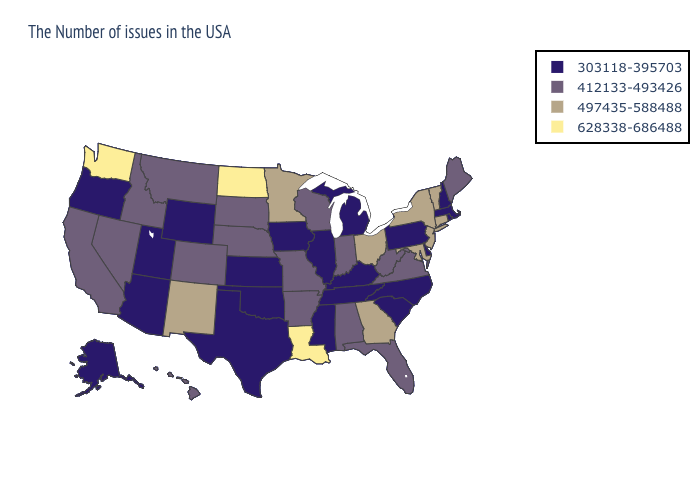Name the states that have a value in the range 497435-588488?
Give a very brief answer. Vermont, Connecticut, New York, New Jersey, Maryland, Ohio, Georgia, Minnesota, New Mexico. Which states have the highest value in the USA?
Quick response, please. Louisiana, North Dakota, Washington. Does South Carolina have the same value as Utah?
Give a very brief answer. Yes. Does Illinois have the lowest value in the USA?
Short answer required. Yes. Does Alabama have the lowest value in the South?
Write a very short answer. No. Which states have the lowest value in the Northeast?
Concise answer only. Massachusetts, Rhode Island, New Hampshire, Pennsylvania. Which states hav the highest value in the Northeast?
Quick response, please. Vermont, Connecticut, New York, New Jersey. Does West Virginia have the highest value in the South?
Concise answer only. No. What is the value of Arizona?
Quick response, please. 303118-395703. Does Alaska have a lower value than Maryland?
Quick response, please. Yes. Name the states that have a value in the range 497435-588488?
Be succinct. Vermont, Connecticut, New York, New Jersey, Maryland, Ohio, Georgia, Minnesota, New Mexico. What is the lowest value in states that border Arkansas?
Write a very short answer. 303118-395703. What is the highest value in the USA?
Concise answer only. 628338-686488. Does South Carolina have the highest value in the USA?
Short answer required. No. Does North Dakota have the highest value in the USA?
Write a very short answer. Yes. 